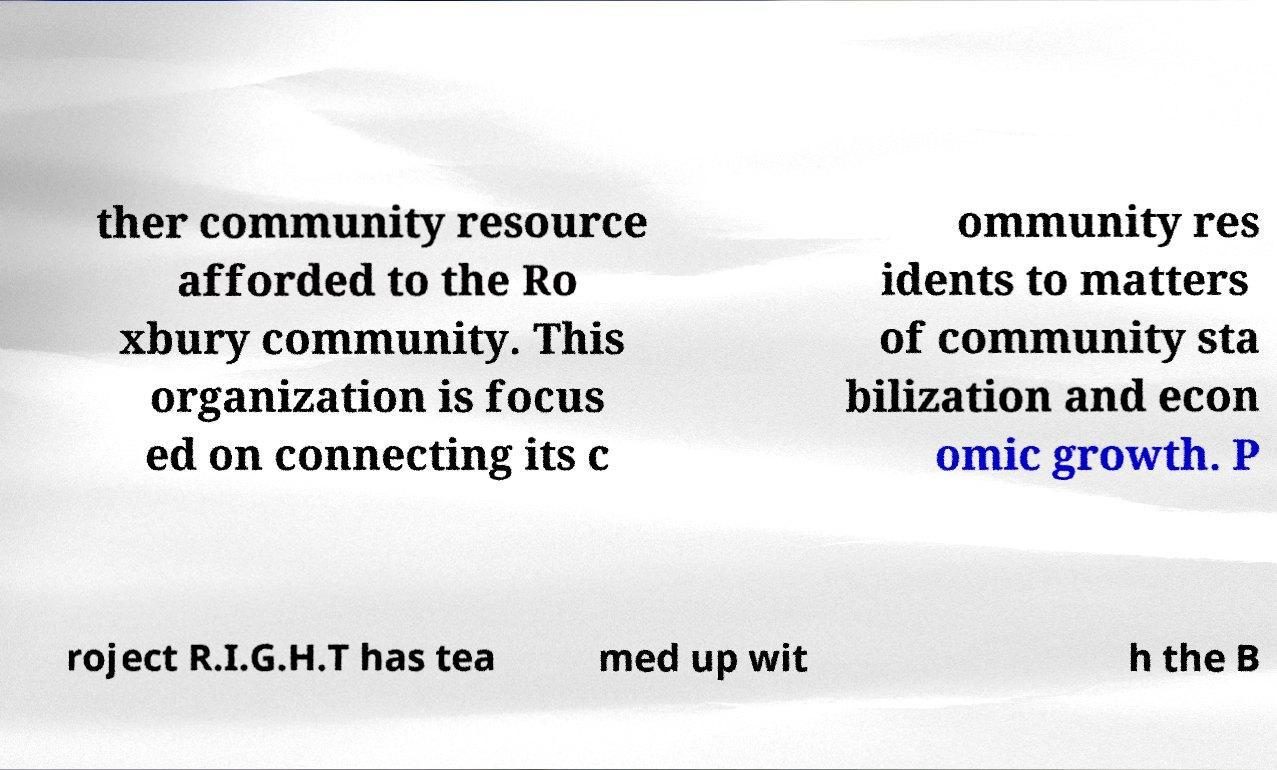Could you assist in decoding the text presented in this image and type it out clearly? ther community resource afforded to the Ro xbury community. This organization is focus ed on connecting its c ommunity res idents to matters of community sta bilization and econ omic growth. P roject R.I.G.H.T has tea med up wit h the B 